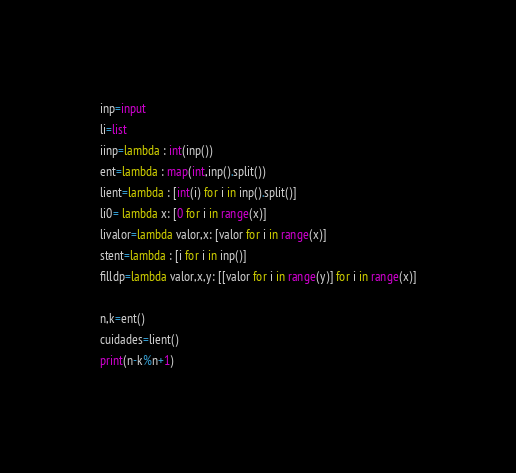<code> <loc_0><loc_0><loc_500><loc_500><_Python_>inp=input
li=list
iinp=lambda : int(inp())
ent=lambda : map(int,inp().split())
lient=lambda : [int(i) for i in inp().split()]
li0= lambda x: [0 for i in range(x)]
livalor=lambda valor,x: [valor for i in range(x)]
stent=lambda : [i for i in inp()]
filldp=lambda valor,x,y: [[valor for i in range(y)] for i in range(x)]

n,k=ent()
cuidades=lient()
print(n-k%n+1)</code> 